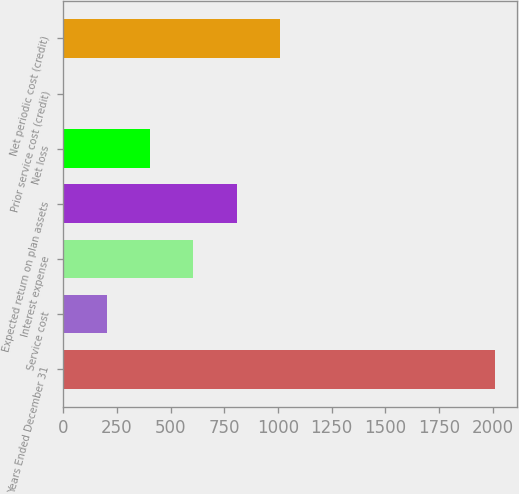Convert chart. <chart><loc_0><loc_0><loc_500><loc_500><bar_chart><fcel>Years Ended December 31<fcel>Service cost<fcel>Interest expense<fcel>Expected return on plan assets<fcel>Net loss<fcel>Prior service cost (credit)<fcel>Net periodic cost (credit)<nl><fcel>2011<fcel>205.6<fcel>606.8<fcel>807.4<fcel>406.2<fcel>5<fcel>1008<nl></chart> 